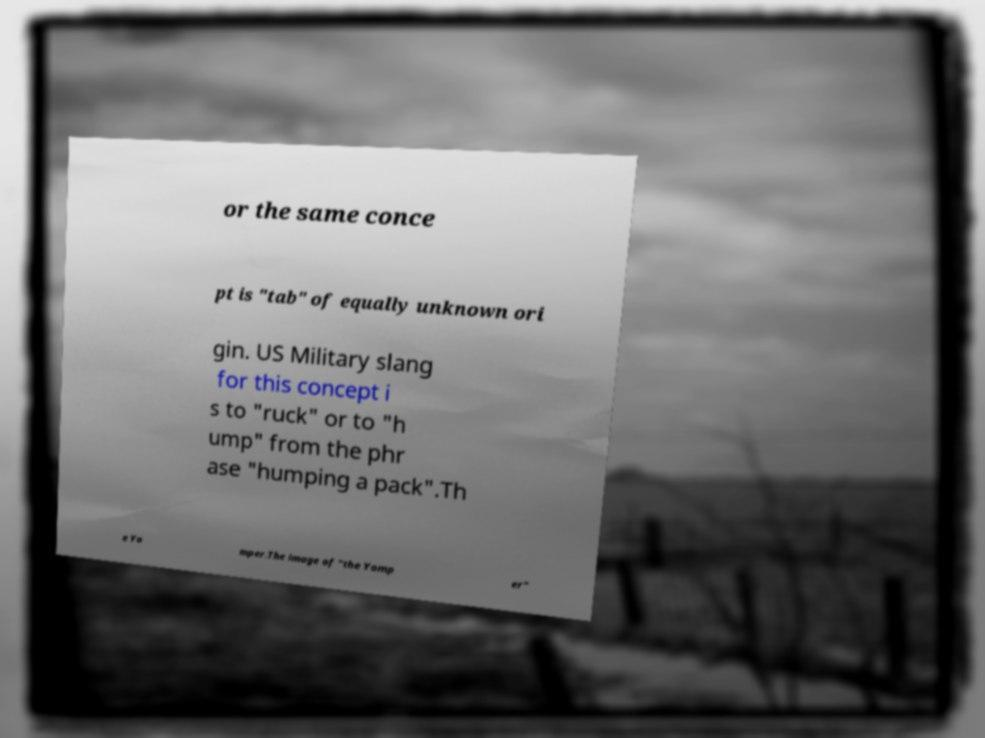Can you accurately transcribe the text from the provided image for me? or the same conce pt is "tab" of equally unknown ori gin. US Military slang for this concept i s to "ruck" or to "h ump" from the phr ase "humping a pack".Th e Yo mper.The image of "the Yomp er" 